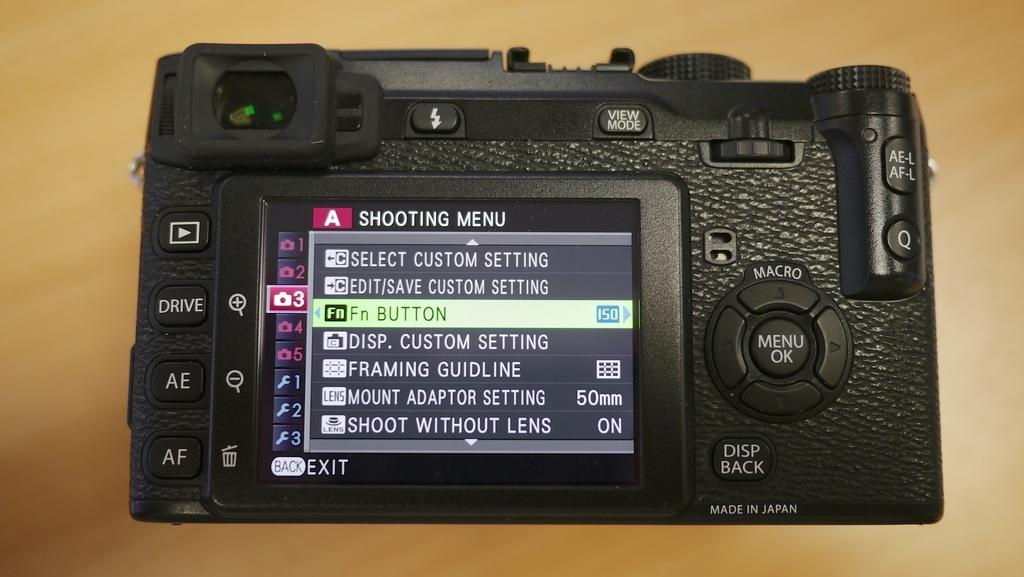How would you summarize this image in a sentence or two? In this picture we can see a camera on a platform, on this camera we can see a screen, on this screen we can see some text and symbols on it. 